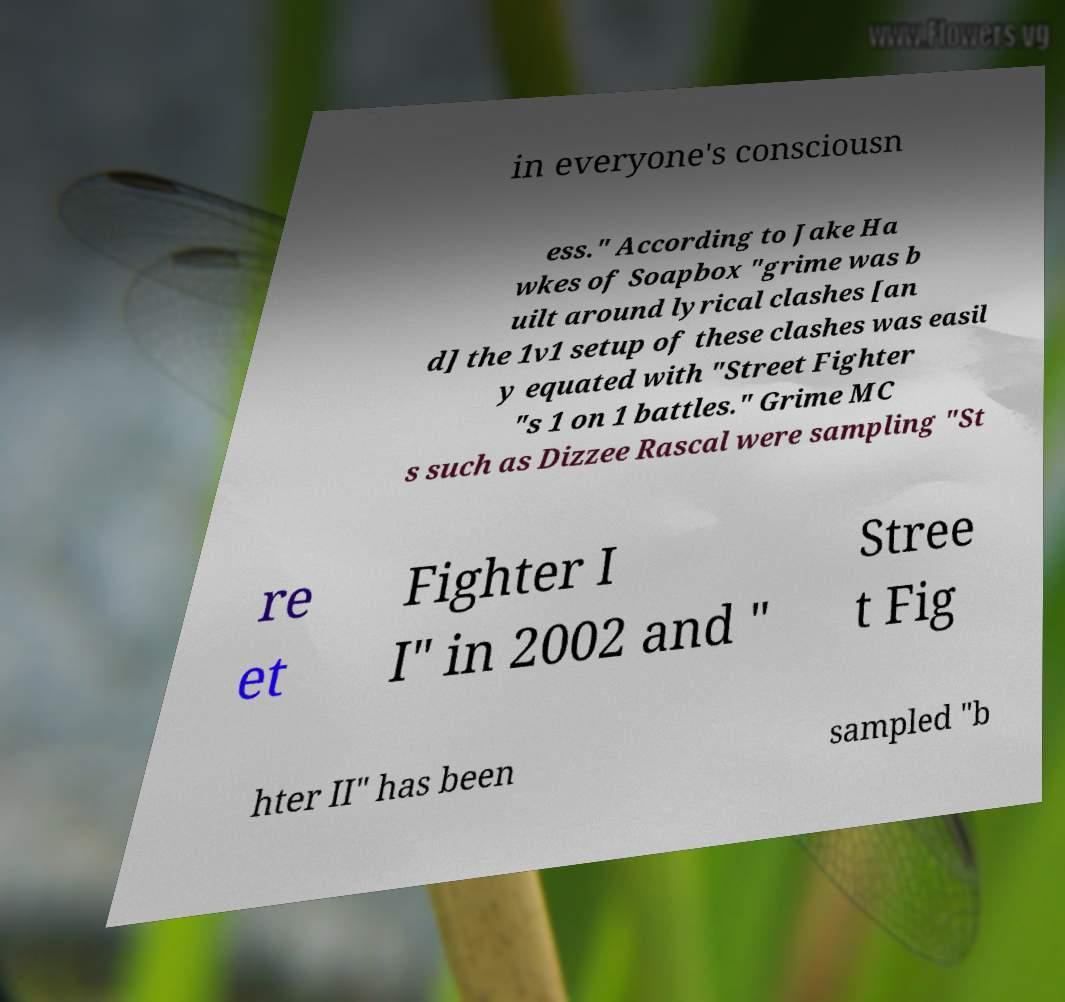Can you accurately transcribe the text from the provided image for me? in everyone's consciousn ess." According to Jake Ha wkes of Soapbox "grime was b uilt around lyrical clashes [an d] the 1v1 setup of these clashes was easil y equated with "Street Fighter "s 1 on 1 battles." Grime MC s such as Dizzee Rascal were sampling "St re et Fighter I I" in 2002 and " Stree t Fig hter II" has been sampled "b 